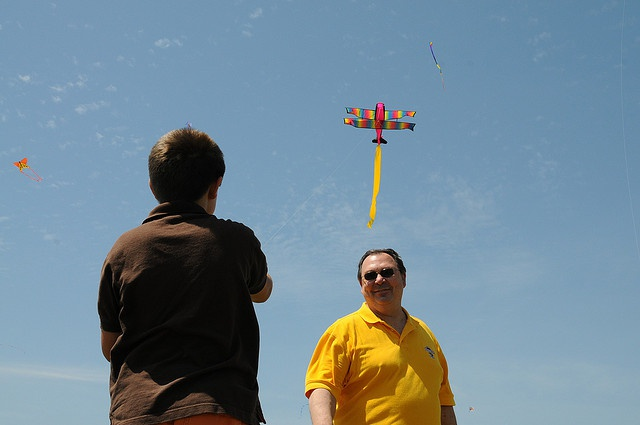Describe the objects in this image and their specific colors. I can see people in gray, black, and maroon tones, people in gray, olive, orange, maroon, and gold tones, kite in gray, orange, gold, brown, and black tones, kite in gray and blue tones, and kite in gray, red, darkgray, and orange tones in this image. 